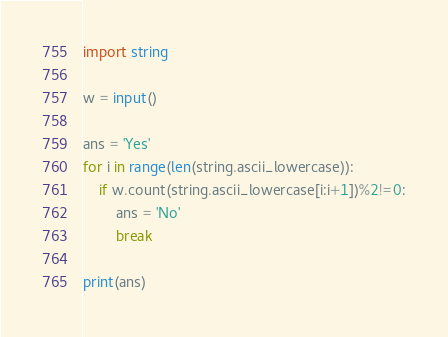Convert code to text. <code><loc_0><loc_0><loc_500><loc_500><_Python_>import string

w = input()

ans = 'Yes'
for i in range(len(string.ascii_lowercase)):
	if w.count(string.ascii_lowercase[i:i+1])%2!=0:
		ans = 'No'
		break

print(ans)</code> 